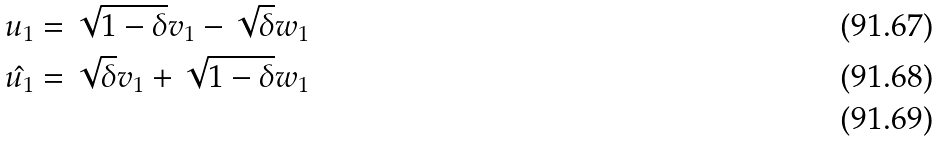Convert formula to latex. <formula><loc_0><loc_0><loc_500><loc_500>u _ { 1 } & = \sqrt { 1 - \delta } v _ { 1 } - \sqrt { \delta } w _ { 1 } \\ \hat { u _ { 1 } } & = \sqrt { \delta } v _ { 1 } + \sqrt { 1 - \delta } w _ { 1 } \\</formula> 